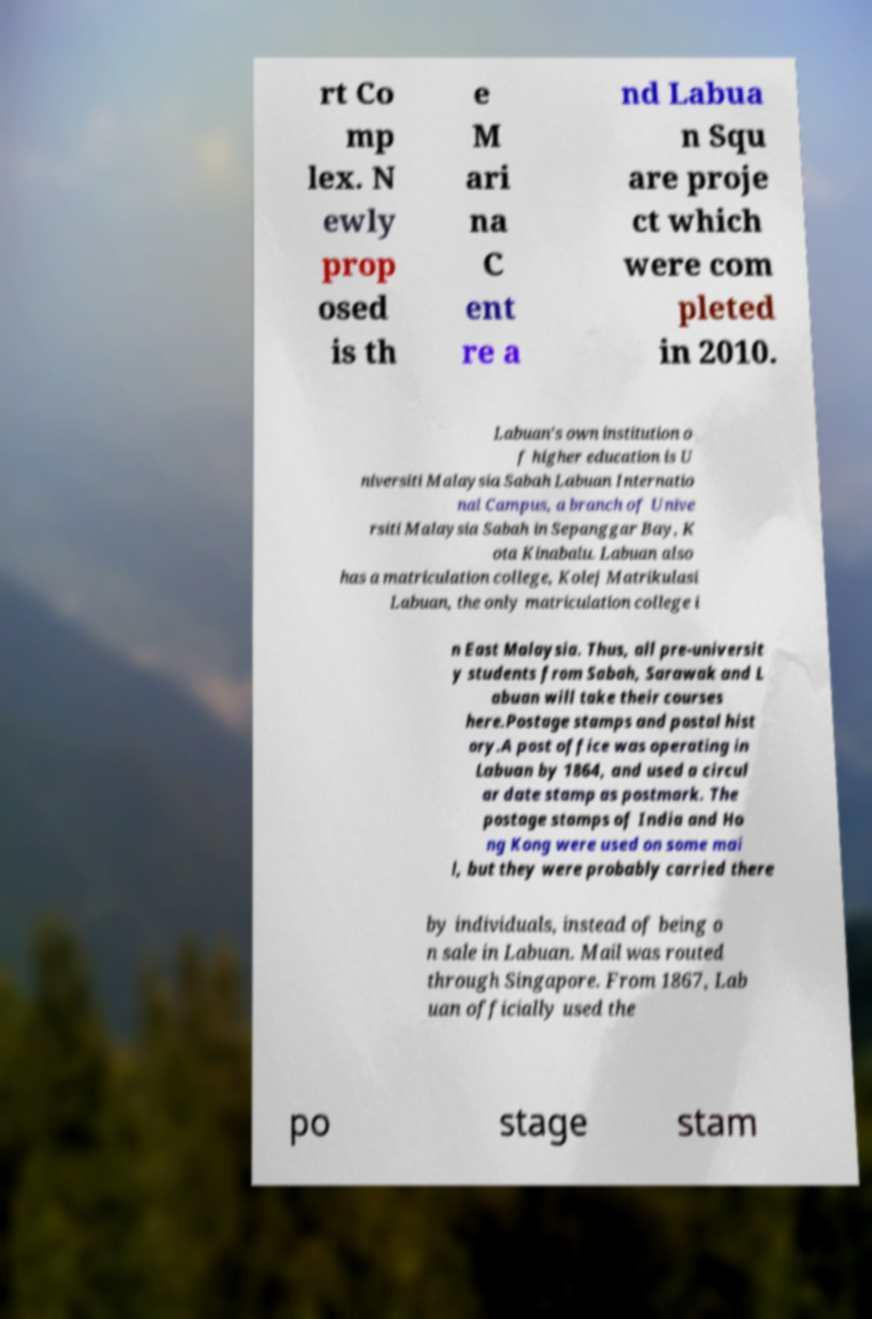Could you assist in decoding the text presented in this image and type it out clearly? rt Co mp lex. N ewly prop osed is th e M ari na C ent re a nd Labua n Squ are proje ct which were com pleted in 2010. Labuan's own institution o f higher education is U niversiti Malaysia Sabah Labuan Internatio nal Campus, a branch of Unive rsiti Malaysia Sabah in Sepanggar Bay, K ota Kinabalu. Labuan also has a matriculation college, Kolej Matrikulasi Labuan, the only matriculation college i n East Malaysia. Thus, all pre-universit y students from Sabah, Sarawak and L abuan will take their courses here.Postage stamps and postal hist ory.A post office was operating in Labuan by 1864, and used a circul ar date stamp as postmark. The postage stamps of India and Ho ng Kong were used on some mai l, but they were probably carried there by individuals, instead of being o n sale in Labuan. Mail was routed through Singapore. From 1867, Lab uan officially used the po stage stam 